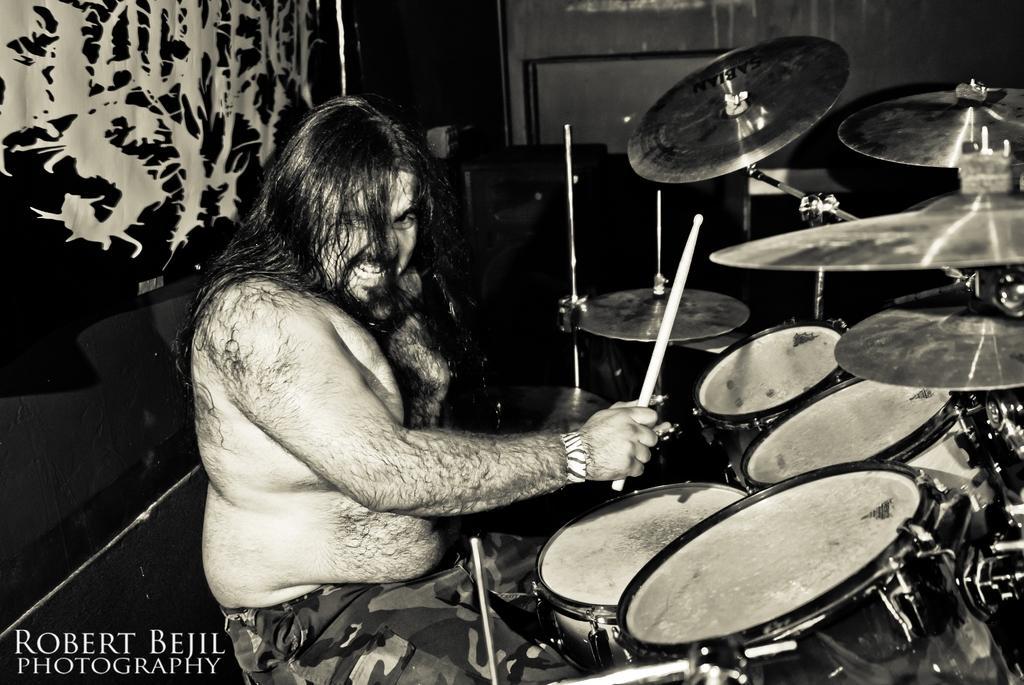Describe this image in one or two sentences. This is a black and white picture. In the center of the picture there is a man playing drums. On the right there are drums. On the left there is a banner. In the background it is the wall. 